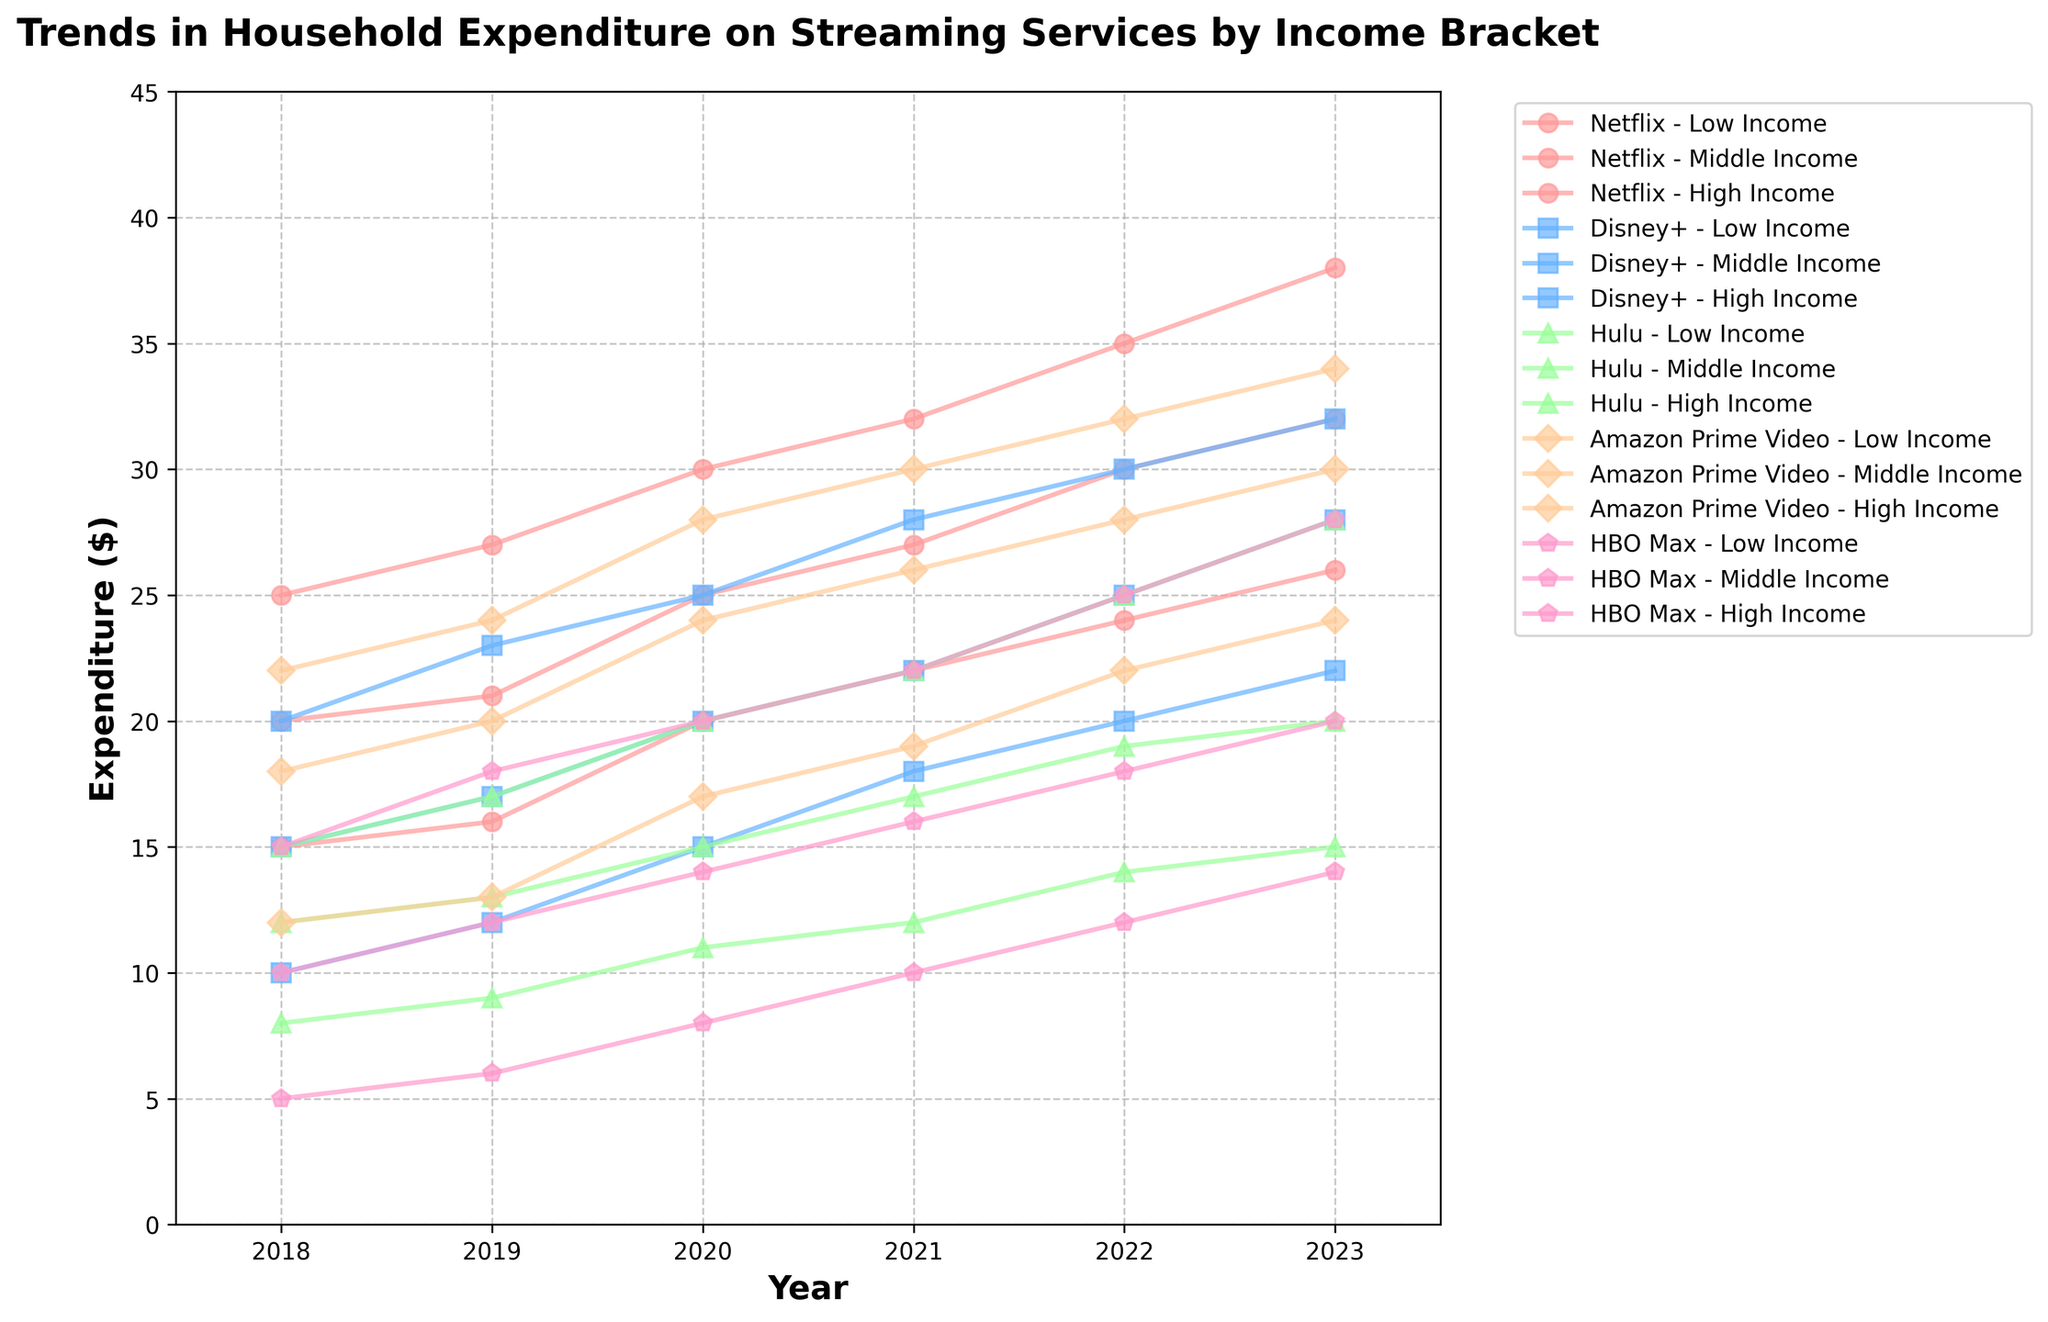What is the title of the figure? The title of the figure is written at the top and usually summarizes what the figure is about.
Answer: Trends in Household Expenditure on Streaming Services by Income Bracket Which streaming service showed the highest expenditure for High Income households in 2023? Look for the data points representing 2023 for High Income households and identify the highest point among the streaming services.
Answer: Netflix What is the trend in expenditure on Hulu for Low Income households from 2018 to 2023? Trace the points for Hulu for Low Income households from 2018 to 2023 to identify if the expenditure is increasing, decreasing, or stable.
Answer: Increasing How did the expenditure on Amazon Prime Video change from 2018 to 2023 for Middle Income households? Examine the values for Amazon Prime Video in 2018 and 2023 for Middle Income households and observe the change.
Answer: Increased Compare the expenditure on Disney+ for Low Income and High Income households in 2021. Find the points for Disney+ for Low Income and High Income households in 2021 and compare the values.
Answer: Higher for High Income Which streaming service has the most consistent expenditure trend across all income brackets from 2018 to 2023? Look at each streaming service's expenditure trend across Low, Middle, and High Income brackets and identify the one with the most similar pattern over the years.
Answer: Netflix What is the expenditure difference between Low Income and High Income households for HBO Max in 2020? Find the data points for HBO Max in 2020 for both income groups and calculate the difference.
Answer: 12 Calculate the average expenditure on Netflix from 2018 to 2023 for Middle Income households. Sum the expenditures on Netflix for Middle Income households from 2018 to 2023 and divide by the number of years (6).
Answer: 25.83 Which service had the lowest expenditure for Low Income households in 2019? Locate the data points for Low Income households in 2019 and identify the lowest expenditure among the services.
Answer: HBO Max 